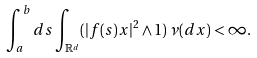Convert formula to latex. <formula><loc_0><loc_0><loc_500><loc_500>\int _ { a } ^ { b } d s \int _ { \mathbb { R } ^ { d } } ( | f ( s ) x | ^ { 2 } \land 1 ) \, \nu ( d x ) < \infty .</formula> 